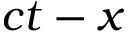<formula> <loc_0><loc_0><loc_500><loc_500>c t - x</formula> 